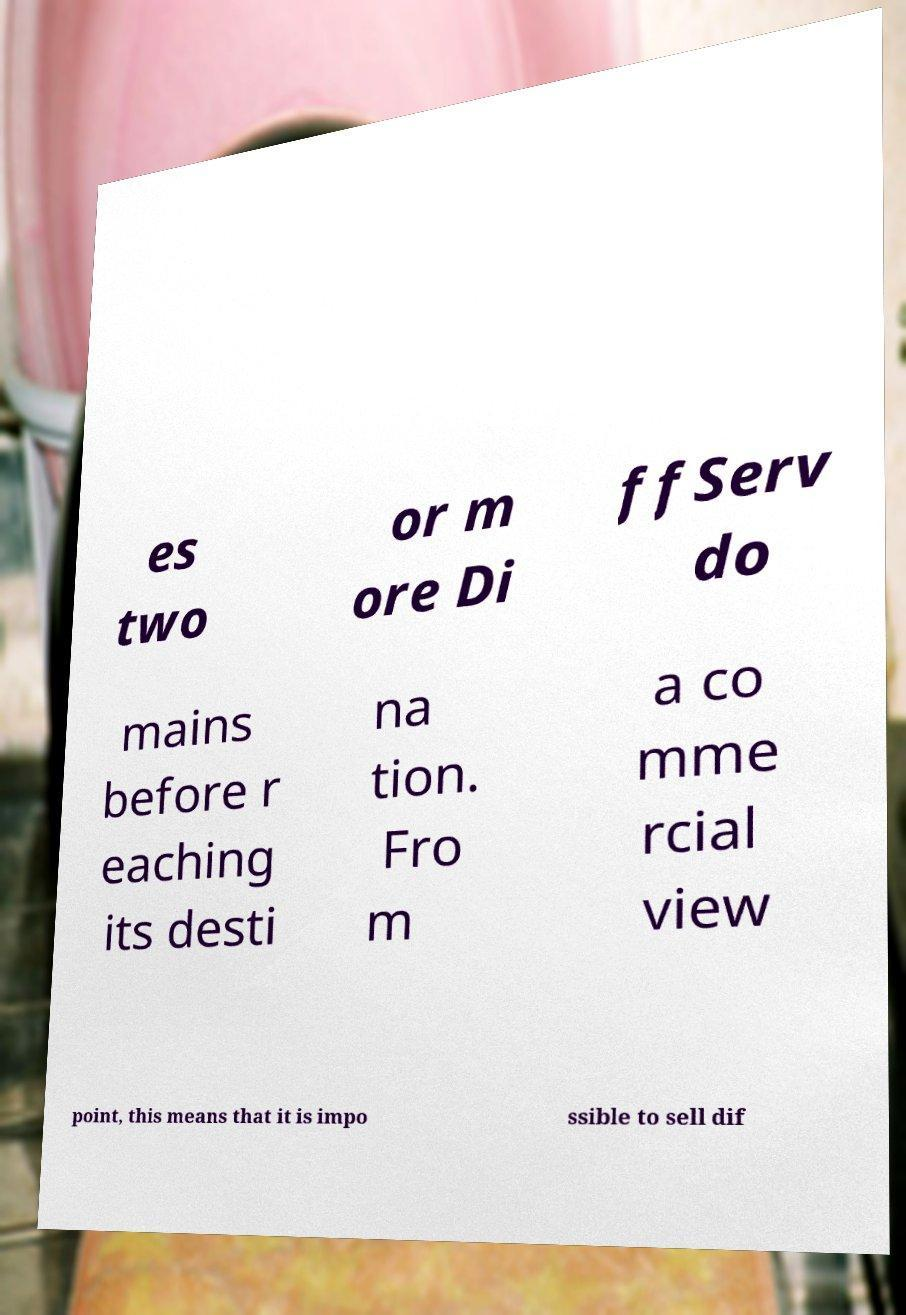There's text embedded in this image that I need extracted. Can you transcribe it verbatim? es two or m ore Di ffServ do mains before r eaching its desti na tion. Fro m a co mme rcial view point, this means that it is impo ssible to sell dif 